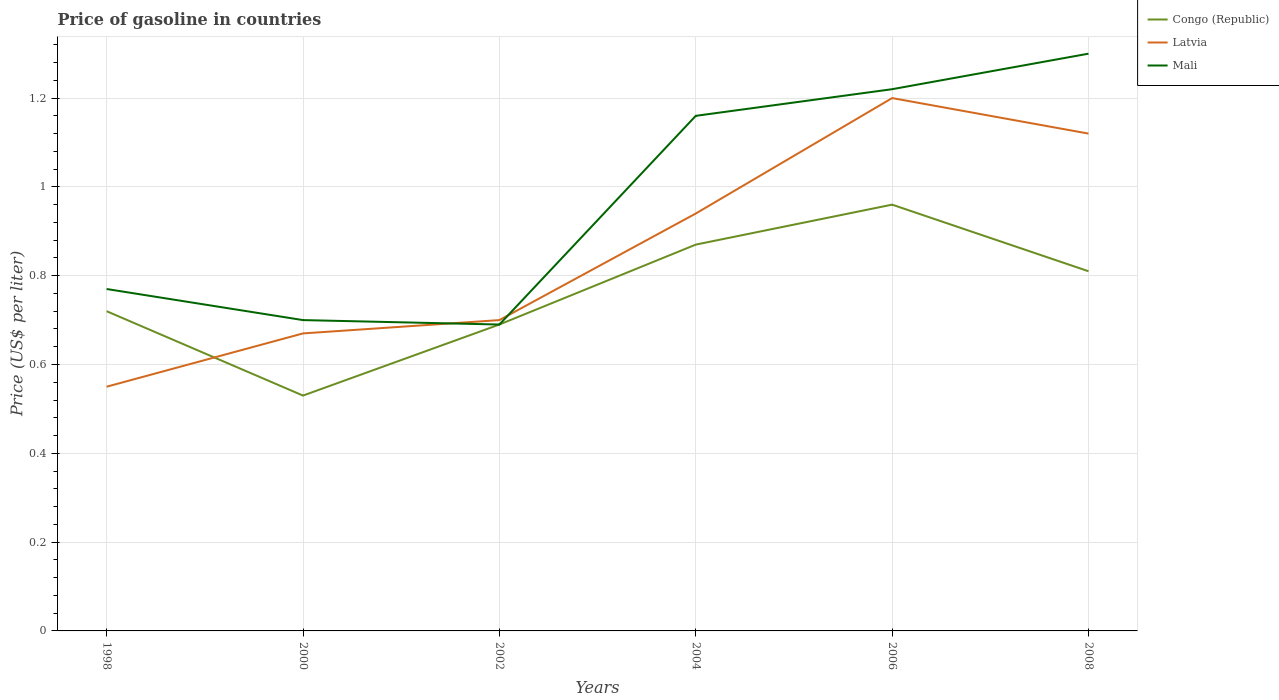How many different coloured lines are there?
Your answer should be very brief. 3. Across all years, what is the maximum price of gasoline in Latvia?
Your response must be concise. 0.55. What is the total price of gasoline in Mali in the graph?
Your answer should be compact. 0.08. What is the difference between the highest and the second highest price of gasoline in Congo (Republic)?
Provide a short and direct response. 0.43. How many years are there in the graph?
Your answer should be compact. 6. Are the values on the major ticks of Y-axis written in scientific E-notation?
Keep it short and to the point. No. Does the graph contain any zero values?
Keep it short and to the point. No. Does the graph contain grids?
Ensure brevity in your answer.  Yes. Where does the legend appear in the graph?
Ensure brevity in your answer.  Top right. How are the legend labels stacked?
Your response must be concise. Vertical. What is the title of the graph?
Make the answer very short. Price of gasoline in countries. Does "Finland" appear as one of the legend labels in the graph?
Provide a short and direct response. No. What is the label or title of the X-axis?
Offer a very short reply. Years. What is the label or title of the Y-axis?
Ensure brevity in your answer.  Price (US$ per liter). What is the Price (US$ per liter) of Congo (Republic) in 1998?
Make the answer very short. 0.72. What is the Price (US$ per liter) of Latvia in 1998?
Keep it short and to the point. 0.55. What is the Price (US$ per liter) in Mali in 1998?
Your response must be concise. 0.77. What is the Price (US$ per liter) in Congo (Republic) in 2000?
Provide a succinct answer. 0.53. What is the Price (US$ per liter) in Latvia in 2000?
Your answer should be very brief. 0.67. What is the Price (US$ per liter) of Mali in 2000?
Make the answer very short. 0.7. What is the Price (US$ per liter) of Congo (Republic) in 2002?
Keep it short and to the point. 0.69. What is the Price (US$ per liter) in Latvia in 2002?
Ensure brevity in your answer.  0.7. What is the Price (US$ per liter) of Mali in 2002?
Provide a short and direct response. 0.69. What is the Price (US$ per liter) in Congo (Republic) in 2004?
Keep it short and to the point. 0.87. What is the Price (US$ per liter) in Mali in 2004?
Offer a very short reply. 1.16. What is the Price (US$ per liter) in Mali in 2006?
Make the answer very short. 1.22. What is the Price (US$ per liter) in Congo (Republic) in 2008?
Ensure brevity in your answer.  0.81. What is the Price (US$ per liter) in Latvia in 2008?
Offer a terse response. 1.12. What is the Price (US$ per liter) of Mali in 2008?
Give a very brief answer. 1.3. Across all years, what is the minimum Price (US$ per liter) in Congo (Republic)?
Provide a succinct answer. 0.53. Across all years, what is the minimum Price (US$ per liter) of Latvia?
Offer a terse response. 0.55. Across all years, what is the minimum Price (US$ per liter) in Mali?
Provide a short and direct response. 0.69. What is the total Price (US$ per liter) of Congo (Republic) in the graph?
Give a very brief answer. 4.58. What is the total Price (US$ per liter) in Latvia in the graph?
Your answer should be very brief. 5.18. What is the total Price (US$ per liter) in Mali in the graph?
Your response must be concise. 5.84. What is the difference between the Price (US$ per liter) in Congo (Republic) in 1998 and that in 2000?
Give a very brief answer. 0.19. What is the difference between the Price (US$ per liter) in Latvia in 1998 and that in 2000?
Your answer should be compact. -0.12. What is the difference between the Price (US$ per liter) in Mali in 1998 and that in 2000?
Offer a terse response. 0.07. What is the difference between the Price (US$ per liter) of Latvia in 1998 and that in 2002?
Keep it short and to the point. -0.15. What is the difference between the Price (US$ per liter) in Mali in 1998 and that in 2002?
Ensure brevity in your answer.  0.08. What is the difference between the Price (US$ per liter) in Congo (Republic) in 1998 and that in 2004?
Make the answer very short. -0.15. What is the difference between the Price (US$ per liter) of Latvia in 1998 and that in 2004?
Offer a terse response. -0.39. What is the difference between the Price (US$ per liter) in Mali in 1998 and that in 2004?
Keep it short and to the point. -0.39. What is the difference between the Price (US$ per liter) in Congo (Republic) in 1998 and that in 2006?
Offer a very short reply. -0.24. What is the difference between the Price (US$ per liter) of Latvia in 1998 and that in 2006?
Make the answer very short. -0.65. What is the difference between the Price (US$ per liter) of Mali in 1998 and that in 2006?
Offer a very short reply. -0.45. What is the difference between the Price (US$ per liter) in Congo (Republic) in 1998 and that in 2008?
Give a very brief answer. -0.09. What is the difference between the Price (US$ per liter) of Latvia in 1998 and that in 2008?
Give a very brief answer. -0.57. What is the difference between the Price (US$ per liter) of Mali in 1998 and that in 2008?
Keep it short and to the point. -0.53. What is the difference between the Price (US$ per liter) in Congo (Republic) in 2000 and that in 2002?
Your answer should be very brief. -0.16. What is the difference between the Price (US$ per liter) in Latvia in 2000 and that in 2002?
Your answer should be compact. -0.03. What is the difference between the Price (US$ per liter) in Mali in 2000 and that in 2002?
Your response must be concise. 0.01. What is the difference between the Price (US$ per liter) in Congo (Republic) in 2000 and that in 2004?
Offer a terse response. -0.34. What is the difference between the Price (US$ per liter) of Latvia in 2000 and that in 2004?
Your answer should be very brief. -0.27. What is the difference between the Price (US$ per liter) of Mali in 2000 and that in 2004?
Your answer should be compact. -0.46. What is the difference between the Price (US$ per liter) in Congo (Republic) in 2000 and that in 2006?
Give a very brief answer. -0.43. What is the difference between the Price (US$ per liter) of Latvia in 2000 and that in 2006?
Offer a very short reply. -0.53. What is the difference between the Price (US$ per liter) of Mali in 2000 and that in 2006?
Your response must be concise. -0.52. What is the difference between the Price (US$ per liter) of Congo (Republic) in 2000 and that in 2008?
Ensure brevity in your answer.  -0.28. What is the difference between the Price (US$ per liter) in Latvia in 2000 and that in 2008?
Give a very brief answer. -0.45. What is the difference between the Price (US$ per liter) of Congo (Republic) in 2002 and that in 2004?
Provide a succinct answer. -0.18. What is the difference between the Price (US$ per liter) in Latvia in 2002 and that in 2004?
Ensure brevity in your answer.  -0.24. What is the difference between the Price (US$ per liter) of Mali in 2002 and that in 2004?
Offer a terse response. -0.47. What is the difference between the Price (US$ per liter) in Congo (Republic) in 2002 and that in 2006?
Your response must be concise. -0.27. What is the difference between the Price (US$ per liter) in Mali in 2002 and that in 2006?
Keep it short and to the point. -0.53. What is the difference between the Price (US$ per liter) in Congo (Republic) in 2002 and that in 2008?
Keep it short and to the point. -0.12. What is the difference between the Price (US$ per liter) in Latvia in 2002 and that in 2008?
Provide a short and direct response. -0.42. What is the difference between the Price (US$ per liter) of Mali in 2002 and that in 2008?
Provide a succinct answer. -0.61. What is the difference between the Price (US$ per liter) in Congo (Republic) in 2004 and that in 2006?
Provide a short and direct response. -0.09. What is the difference between the Price (US$ per liter) of Latvia in 2004 and that in 2006?
Provide a succinct answer. -0.26. What is the difference between the Price (US$ per liter) of Mali in 2004 and that in 2006?
Make the answer very short. -0.06. What is the difference between the Price (US$ per liter) of Latvia in 2004 and that in 2008?
Make the answer very short. -0.18. What is the difference between the Price (US$ per liter) of Mali in 2004 and that in 2008?
Offer a very short reply. -0.14. What is the difference between the Price (US$ per liter) in Congo (Republic) in 2006 and that in 2008?
Offer a terse response. 0.15. What is the difference between the Price (US$ per liter) of Latvia in 2006 and that in 2008?
Offer a terse response. 0.08. What is the difference between the Price (US$ per liter) in Mali in 2006 and that in 2008?
Your response must be concise. -0.08. What is the difference between the Price (US$ per liter) in Congo (Republic) in 1998 and the Price (US$ per liter) in Latvia in 2000?
Provide a succinct answer. 0.05. What is the difference between the Price (US$ per liter) in Congo (Republic) in 1998 and the Price (US$ per liter) in Mali in 2000?
Provide a short and direct response. 0.02. What is the difference between the Price (US$ per liter) of Congo (Republic) in 1998 and the Price (US$ per liter) of Latvia in 2002?
Your answer should be very brief. 0.02. What is the difference between the Price (US$ per liter) of Latvia in 1998 and the Price (US$ per liter) of Mali in 2002?
Offer a very short reply. -0.14. What is the difference between the Price (US$ per liter) of Congo (Republic) in 1998 and the Price (US$ per liter) of Latvia in 2004?
Your answer should be compact. -0.22. What is the difference between the Price (US$ per liter) of Congo (Republic) in 1998 and the Price (US$ per liter) of Mali in 2004?
Offer a terse response. -0.44. What is the difference between the Price (US$ per liter) of Latvia in 1998 and the Price (US$ per liter) of Mali in 2004?
Offer a very short reply. -0.61. What is the difference between the Price (US$ per liter) in Congo (Republic) in 1998 and the Price (US$ per liter) in Latvia in 2006?
Offer a very short reply. -0.48. What is the difference between the Price (US$ per liter) in Latvia in 1998 and the Price (US$ per liter) in Mali in 2006?
Give a very brief answer. -0.67. What is the difference between the Price (US$ per liter) in Congo (Republic) in 1998 and the Price (US$ per liter) in Mali in 2008?
Give a very brief answer. -0.58. What is the difference between the Price (US$ per liter) in Latvia in 1998 and the Price (US$ per liter) in Mali in 2008?
Your answer should be compact. -0.75. What is the difference between the Price (US$ per liter) of Congo (Republic) in 2000 and the Price (US$ per liter) of Latvia in 2002?
Ensure brevity in your answer.  -0.17. What is the difference between the Price (US$ per liter) of Congo (Republic) in 2000 and the Price (US$ per liter) of Mali in 2002?
Ensure brevity in your answer.  -0.16. What is the difference between the Price (US$ per liter) in Latvia in 2000 and the Price (US$ per liter) in Mali in 2002?
Make the answer very short. -0.02. What is the difference between the Price (US$ per liter) of Congo (Republic) in 2000 and the Price (US$ per liter) of Latvia in 2004?
Give a very brief answer. -0.41. What is the difference between the Price (US$ per liter) of Congo (Republic) in 2000 and the Price (US$ per liter) of Mali in 2004?
Give a very brief answer. -0.63. What is the difference between the Price (US$ per liter) in Latvia in 2000 and the Price (US$ per liter) in Mali in 2004?
Provide a short and direct response. -0.49. What is the difference between the Price (US$ per liter) of Congo (Republic) in 2000 and the Price (US$ per liter) of Latvia in 2006?
Your response must be concise. -0.67. What is the difference between the Price (US$ per liter) in Congo (Republic) in 2000 and the Price (US$ per liter) in Mali in 2006?
Your answer should be very brief. -0.69. What is the difference between the Price (US$ per liter) in Latvia in 2000 and the Price (US$ per liter) in Mali in 2006?
Provide a short and direct response. -0.55. What is the difference between the Price (US$ per liter) in Congo (Republic) in 2000 and the Price (US$ per liter) in Latvia in 2008?
Give a very brief answer. -0.59. What is the difference between the Price (US$ per liter) in Congo (Republic) in 2000 and the Price (US$ per liter) in Mali in 2008?
Offer a very short reply. -0.77. What is the difference between the Price (US$ per liter) in Latvia in 2000 and the Price (US$ per liter) in Mali in 2008?
Provide a short and direct response. -0.63. What is the difference between the Price (US$ per liter) of Congo (Republic) in 2002 and the Price (US$ per liter) of Latvia in 2004?
Your answer should be very brief. -0.25. What is the difference between the Price (US$ per liter) of Congo (Republic) in 2002 and the Price (US$ per liter) of Mali in 2004?
Give a very brief answer. -0.47. What is the difference between the Price (US$ per liter) in Latvia in 2002 and the Price (US$ per liter) in Mali in 2004?
Provide a succinct answer. -0.46. What is the difference between the Price (US$ per liter) of Congo (Republic) in 2002 and the Price (US$ per liter) of Latvia in 2006?
Make the answer very short. -0.51. What is the difference between the Price (US$ per liter) in Congo (Republic) in 2002 and the Price (US$ per liter) in Mali in 2006?
Provide a short and direct response. -0.53. What is the difference between the Price (US$ per liter) in Latvia in 2002 and the Price (US$ per liter) in Mali in 2006?
Offer a terse response. -0.52. What is the difference between the Price (US$ per liter) in Congo (Republic) in 2002 and the Price (US$ per liter) in Latvia in 2008?
Make the answer very short. -0.43. What is the difference between the Price (US$ per liter) in Congo (Republic) in 2002 and the Price (US$ per liter) in Mali in 2008?
Your answer should be compact. -0.61. What is the difference between the Price (US$ per liter) in Congo (Republic) in 2004 and the Price (US$ per liter) in Latvia in 2006?
Your response must be concise. -0.33. What is the difference between the Price (US$ per liter) in Congo (Republic) in 2004 and the Price (US$ per liter) in Mali in 2006?
Your answer should be very brief. -0.35. What is the difference between the Price (US$ per liter) of Latvia in 2004 and the Price (US$ per liter) of Mali in 2006?
Offer a very short reply. -0.28. What is the difference between the Price (US$ per liter) in Congo (Republic) in 2004 and the Price (US$ per liter) in Latvia in 2008?
Provide a short and direct response. -0.25. What is the difference between the Price (US$ per liter) of Congo (Republic) in 2004 and the Price (US$ per liter) of Mali in 2008?
Your answer should be compact. -0.43. What is the difference between the Price (US$ per liter) of Latvia in 2004 and the Price (US$ per liter) of Mali in 2008?
Ensure brevity in your answer.  -0.36. What is the difference between the Price (US$ per liter) of Congo (Republic) in 2006 and the Price (US$ per liter) of Latvia in 2008?
Offer a terse response. -0.16. What is the difference between the Price (US$ per liter) of Congo (Republic) in 2006 and the Price (US$ per liter) of Mali in 2008?
Give a very brief answer. -0.34. What is the difference between the Price (US$ per liter) of Latvia in 2006 and the Price (US$ per liter) of Mali in 2008?
Your response must be concise. -0.1. What is the average Price (US$ per liter) of Congo (Republic) per year?
Offer a very short reply. 0.76. What is the average Price (US$ per liter) in Latvia per year?
Provide a succinct answer. 0.86. What is the average Price (US$ per liter) of Mali per year?
Your answer should be compact. 0.97. In the year 1998, what is the difference between the Price (US$ per liter) in Congo (Republic) and Price (US$ per liter) in Latvia?
Your answer should be very brief. 0.17. In the year 1998, what is the difference between the Price (US$ per liter) of Congo (Republic) and Price (US$ per liter) of Mali?
Your answer should be compact. -0.05. In the year 1998, what is the difference between the Price (US$ per liter) of Latvia and Price (US$ per liter) of Mali?
Ensure brevity in your answer.  -0.22. In the year 2000, what is the difference between the Price (US$ per liter) of Congo (Republic) and Price (US$ per liter) of Latvia?
Make the answer very short. -0.14. In the year 2000, what is the difference between the Price (US$ per liter) of Congo (Republic) and Price (US$ per liter) of Mali?
Give a very brief answer. -0.17. In the year 2000, what is the difference between the Price (US$ per liter) of Latvia and Price (US$ per liter) of Mali?
Ensure brevity in your answer.  -0.03. In the year 2002, what is the difference between the Price (US$ per liter) of Congo (Republic) and Price (US$ per liter) of Latvia?
Give a very brief answer. -0.01. In the year 2002, what is the difference between the Price (US$ per liter) in Congo (Republic) and Price (US$ per liter) in Mali?
Your answer should be very brief. 0. In the year 2004, what is the difference between the Price (US$ per liter) in Congo (Republic) and Price (US$ per liter) in Latvia?
Offer a terse response. -0.07. In the year 2004, what is the difference between the Price (US$ per liter) in Congo (Republic) and Price (US$ per liter) in Mali?
Make the answer very short. -0.29. In the year 2004, what is the difference between the Price (US$ per liter) in Latvia and Price (US$ per liter) in Mali?
Provide a short and direct response. -0.22. In the year 2006, what is the difference between the Price (US$ per liter) of Congo (Republic) and Price (US$ per liter) of Latvia?
Your answer should be very brief. -0.24. In the year 2006, what is the difference between the Price (US$ per liter) of Congo (Republic) and Price (US$ per liter) of Mali?
Your answer should be compact. -0.26. In the year 2006, what is the difference between the Price (US$ per liter) in Latvia and Price (US$ per liter) in Mali?
Your response must be concise. -0.02. In the year 2008, what is the difference between the Price (US$ per liter) in Congo (Republic) and Price (US$ per liter) in Latvia?
Your response must be concise. -0.31. In the year 2008, what is the difference between the Price (US$ per liter) in Congo (Republic) and Price (US$ per liter) in Mali?
Provide a succinct answer. -0.49. In the year 2008, what is the difference between the Price (US$ per liter) of Latvia and Price (US$ per liter) of Mali?
Keep it short and to the point. -0.18. What is the ratio of the Price (US$ per liter) in Congo (Republic) in 1998 to that in 2000?
Make the answer very short. 1.36. What is the ratio of the Price (US$ per liter) of Latvia in 1998 to that in 2000?
Make the answer very short. 0.82. What is the ratio of the Price (US$ per liter) of Congo (Republic) in 1998 to that in 2002?
Provide a succinct answer. 1.04. What is the ratio of the Price (US$ per liter) in Latvia in 1998 to that in 2002?
Provide a succinct answer. 0.79. What is the ratio of the Price (US$ per liter) in Mali in 1998 to that in 2002?
Your answer should be compact. 1.12. What is the ratio of the Price (US$ per liter) in Congo (Republic) in 1998 to that in 2004?
Provide a short and direct response. 0.83. What is the ratio of the Price (US$ per liter) in Latvia in 1998 to that in 2004?
Keep it short and to the point. 0.59. What is the ratio of the Price (US$ per liter) in Mali in 1998 to that in 2004?
Keep it short and to the point. 0.66. What is the ratio of the Price (US$ per liter) of Latvia in 1998 to that in 2006?
Offer a terse response. 0.46. What is the ratio of the Price (US$ per liter) of Mali in 1998 to that in 2006?
Your answer should be compact. 0.63. What is the ratio of the Price (US$ per liter) in Latvia in 1998 to that in 2008?
Give a very brief answer. 0.49. What is the ratio of the Price (US$ per liter) of Mali in 1998 to that in 2008?
Ensure brevity in your answer.  0.59. What is the ratio of the Price (US$ per liter) of Congo (Republic) in 2000 to that in 2002?
Make the answer very short. 0.77. What is the ratio of the Price (US$ per liter) of Latvia in 2000 to that in 2002?
Provide a short and direct response. 0.96. What is the ratio of the Price (US$ per liter) of Mali in 2000 to that in 2002?
Make the answer very short. 1.01. What is the ratio of the Price (US$ per liter) of Congo (Republic) in 2000 to that in 2004?
Offer a very short reply. 0.61. What is the ratio of the Price (US$ per liter) of Latvia in 2000 to that in 2004?
Ensure brevity in your answer.  0.71. What is the ratio of the Price (US$ per liter) of Mali in 2000 to that in 2004?
Keep it short and to the point. 0.6. What is the ratio of the Price (US$ per liter) in Congo (Republic) in 2000 to that in 2006?
Keep it short and to the point. 0.55. What is the ratio of the Price (US$ per liter) in Latvia in 2000 to that in 2006?
Offer a very short reply. 0.56. What is the ratio of the Price (US$ per liter) of Mali in 2000 to that in 2006?
Make the answer very short. 0.57. What is the ratio of the Price (US$ per liter) in Congo (Republic) in 2000 to that in 2008?
Make the answer very short. 0.65. What is the ratio of the Price (US$ per liter) in Latvia in 2000 to that in 2008?
Provide a short and direct response. 0.6. What is the ratio of the Price (US$ per liter) of Mali in 2000 to that in 2008?
Your response must be concise. 0.54. What is the ratio of the Price (US$ per liter) in Congo (Republic) in 2002 to that in 2004?
Provide a short and direct response. 0.79. What is the ratio of the Price (US$ per liter) of Latvia in 2002 to that in 2004?
Provide a succinct answer. 0.74. What is the ratio of the Price (US$ per liter) of Mali in 2002 to that in 2004?
Keep it short and to the point. 0.59. What is the ratio of the Price (US$ per liter) in Congo (Republic) in 2002 to that in 2006?
Make the answer very short. 0.72. What is the ratio of the Price (US$ per liter) in Latvia in 2002 to that in 2006?
Provide a short and direct response. 0.58. What is the ratio of the Price (US$ per liter) of Mali in 2002 to that in 2006?
Your answer should be very brief. 0.57. What is the ratio of the Price (US$ per liter) of Congo (Republic) in 2002 to that in 2008?
Your response must be concise. 0.85. What is the ratio of the Price (US$ per liter) of Mali in 2002 to that in 2008?
Make the answer very short. 0.53. What is the ratio of the Price (US$ per liter) of Congo (Republic) in 2004 to that in 2006?
Provide a short and direct response. 0.91. What is the ratio of the Price (US$ per liter) in Latvia in 2004 to that in 2006?
Your response must be concise. 0.78. What is the ratio of the Price (US$ per liter) of Mali in 2004 to that in 2006?
Make the answer very short. 0.95. What is the ratio of the Price (US$ per liter) of Congo (Republic) in 2004 to that in 2008?
Offer a terse response. 1.07. What is the ratio of the Price (US$ per liter) of Latvia in 2004 to that in 2008?
Ensure brevity in your answer.  0.84. What is the ratio of the Price (US$ per liter) of Mali in 2004 to that in 2008?
Provide a short and direct response. 0.89. What is the ratio of the Price (US$ per liter) in Congo (Republic) in 2006 to that in 2008?
Ensure brevity in your answer.  1.19. What is the ratio of the Price (US$ per liter) of Latvia in 2006 to that in 2008?
Provide a short and direct response. 1.07. What is the ratio of the Price (US$ per liter) in Mali in 2006 to that in 2008?
Your answer should be very brief. 0.94. What is the difference between the highest and the second highest Price (US$ per liter) of Congo (Republic)?
Ensure brevity in your answer.  0.09. What is the difference between the highest and the second highest Price (US$ per liter) of Mali?
Make the answer very short. 0.08. What is the difference between the highest and the lowest Price (US$ per liter) in Congo (Republic)?
Your answer should be very brief. 0.43. What is the difference between the highest and the lowest Price (US$ per liter) in Latvia?
Provide a short and direct response. 0.65. What is the difference between the highest and the lowest Price (US$ per liter) of Mali?
Offer a very short reply. 0.61. 